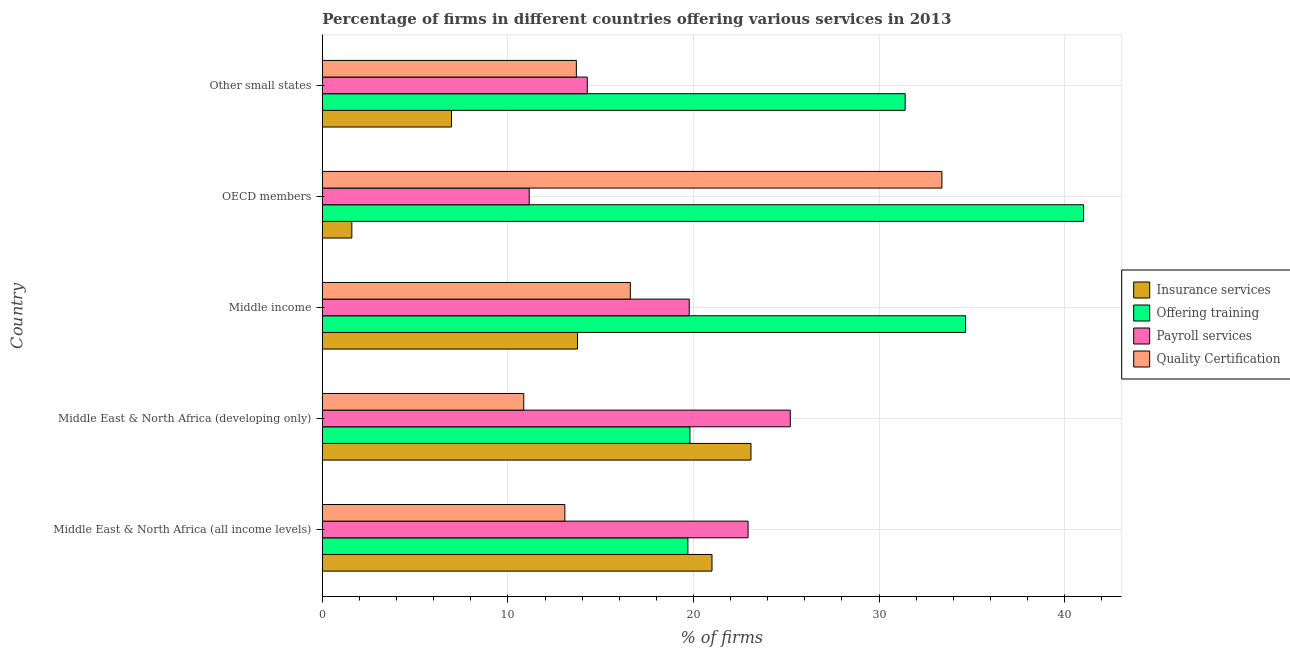How many groups of bars are there?
Provide a succinct answer. 5. Are the number of bars per tick equal to the number of legend labels?
Make the answer very short. Yes. How many bars are there on the 3rd tick from the bottom?
Offer a very short reply. 4. What is the label of the 4th group of bars from the top?
Provide a succinct answer. Middle East & North Africa (developing only). In how many cases, is the number of bars for a given country not equal to the number of legend labels?
Provide a short and direct response. 0. What is the percentage of firms offering quality certification in OECD members?
Keep it short and to the point. 33.39. Across all countries, what is the maximum percentage of firms offering quality certification?
Give a very brief answer. 33.39. Across all countries, what is the minimum percentage of firms offering insurance services?
Provide a succinct answer. 1.59. In which country was the percentage of firms offering payroll services maximum?
Offer a terse response. Middle East & North Africa (developing only). In which country was the percentage of firms offering quality certification minimum?
Offer a very short reply. Middle East & North Africa (developing only). What is the total percentage of firms offering quality certification in the graph?
Offer a terse response. 87.61. What is the difference between the percentage of firms offering insurance services in Middle income and that in Other small states?
Provide a short and direct response. 6.79. What is the difference between the percentage of firms offering quality certification in Middle income and the percentage of firms offering insurance services in Other small states?
Offer a very short reply. 9.64. What is the average percentage of firms offering payroll services per country?
Provide a succinct answer. 18.67. What is the difference between the percentage of firms offering payroll services and percentage of firms offering training in Other small states?
Your answer should be very brief. -17.13. In how many countries, is the percentage of firms offering quality certification greater than 24 %?
Provide a succinct answer. 1. What is the ratio of the percentage of firms offering insurance services in Middle East & North Africa (all income levels) to that in Middle income?
Your response must be concise. 1.53. Is the percentage of firms offering payroll services in Middle East & North Africa (developing only) less than that in OECD members?
Ensure brevity in your answer.  No. What is the difference between the highest and the second highest percentage of firms offering training?
Your answer should be compact. 6.36. What is the difference between the highest and the lowest percentage of firms offering insurance services?
Provide a short and direct response. 21.51. Is the sum of the percentage of firms offering training in Middle income and OECD members greater than the maximum percentage of firms offering insurance services across all countries?
Provide a succinct answer. Yes. Is it the case that in every country, the sum of the percentage of firms offering training and percentage of firms offering quality certification is greater than the sum of percentage of firms offering insurance services and percentage of firms offering payroll services?
Your answer should be compact. No. What does the 2nd bar from the top in Middle East & North Africa (developing only) represents?
Make the answer very short. Payroll services. What does the 3rd bar from the bottom in Other small states represents?
Your response must be concise. Payroll services. Is it the case that in every country, the sum of the percentage of firms offering insurance services and percentage of firms offering training is greater than the percentage of firms offering payroll services?
Your answer should be very brief. Yes. Are all the bars in the graph horizontal?
Keep it short and to the point. Yes. How many countries are there in the graph?
Keep it short and to the point. 5. What is the difference between two consecutive major ticks on the X-axis?
Give a very brief answer. 10. Does the graph contain grids?
Keep it short and to the point. Yes. What is the title of the graph?
Ensure brevity in your answer.  Percentage of firms in different countries offering various services in 2013. What is the label or title of the X-axis?
Offer a terse response. % of firms. What is the % of firms of Insurance services in Middle East & North Africa (all income levels)?
Keep it short and to the point. 21. What is the % of firms in Offering training in Middle East & North Africa (all income levels)?
Offer a terse response. 19.7. What is the % of firms of Payroll services in Middle East & North Africa (all income levels)?
Give a very brief answer. 22.95. What is the % of firms of Quality Certification in Middle East & North Africa (all income levels)?
Provide a short and direct response. 13.07. What is the % of firms of Insurance services in Middle East & North Africa (developing only)?
Your answer should be compact. 23.1. What is the % of firms of Offering training in Middle East & North Africa (developing only)?
Make the answer very short. 19.81. What is the % of firms in Payroll services in Middle East & North Africa (developing only)?
Offer a very short reply. 25.22. What is the % of firms in Quality Certification in Middle East & North Africa (developing only)?
Offer a very short reply. 10.86. What is the % of firms in Insurance services in Middle income?
Keep it short and to the point. 13.75. What is the % of firms of Offering training in Middle income?
Offer a very short reply. 34.66. What is the % of firms in Payroll services in Middle income?
Offer a very short reply. 19.77. What is the % of firms in Quality Certification in Middle income?
Your answer should be very brief. 16.6. What is the % of firms in Insurance services in OECD members?
Provide a succinct answer. 1.59. What is the % of firms of Offering training in OECD members?
Provide a short and direct response. 41.03. What is the % of firms in Payroll services in OECD members?
Your answer should be compact. 11.15. What is the % of firms of Quality Certification in OECD members?
Provide a short and direct response. 33.39. What is the % of firms of Insurance services in Other small states?
Your answer should be very brief. 6.96. What is the % of firms of Offering training in Other small states?
Your response must be concise. 31.41. What is the % of firms in Payroll services in Other small states?
Offer a terse response. 14.28. What is the % of firms of Quality Certification in Other small states?
Make the answer very short. 13.69. Across all countries, what is the maximum % of firms in Insurance services?
Your response must be concise. 23.1. Across all countries, what is the maximum % of firms in Offering training?
Offer a terse response. 41.03. Across all countries, what is the maximum % of firms of Payroll services?
Your response must be concise. 25.22. Across all countries, what is the maximum % of firms of Quality Certification?
Offer a very short reply. 33.39. Across all countries, what is the minimum % of firms of Insurance services?
Keep it short and to the point. 1.59. Across all countries, what is the minimum % of firms of Payroll services?
Ensure brevity in your answer.  11.15. Across all countries, what is the minimum % of firms of Quality Certification?
Offer a terse response. 10.86. What is the total % of firms in Insurance services in the graph?
Your answer should be compact. 66.4. What is the total % of firms of Offering training in the graph?
Keep it short and to the point. 146.61. What is the total % of firms in Payroll services in the graph?
Your response must be concise. 93.37. What is the total % of firms of Quality Certification in the graph?
Your answer should be very brief. 87.61. What is the difference between the % of firms of Insurance services in Middle East & North Africa (all income levels) and that in Middle East & North Africa (developing only)?
Your answer should be very brief. -2.1. What is the difference between the % of firms of Offering training in Middle East & North Africa (all income levels) and that in Middle East & North Africa (developing only)?
Your response must be concise. -0.11. What is the difference between the % of firms of Payroll services in Middle East & North Africa (all income levels) and that in Middle East & North Africa (developing only)?
Provide a succinct answer. -2.27. What is the difference between the % of firms of Quality Certification in Middle East & North Africa (all income levels) and that in Middle East & North Africa (developing only)?
Keep it short and to the point. 2.21. What is the difference between the % of firms of Insurance services in Middle East & North Africa (all income levels) and that in Middle income?
Provide a short and direct response. 7.25. What is the difference between the % of firms in Offering training in Middle East & North Africa (all income levels) and that in Middle income?
Ensure brevity in your answer.  -14.96. What is the difference between the % of firms of Payroll services in Middle East & North Africa (all income levels) and that in Middle income?
Your answer should be very brief. 3.17. What is the difference between the % of firms of Quality Certification in Middle East & North Africa (all income levels) and that in Middle income?
Make the answer very short. -3.53. What is the difference between the % of firms of Insurance services in Middle East & North Africa (all income levels) and that in OECD members?
Ensure brevity in your answer.  19.41. What is the difference between the % of firms of Offering training in Middle East & North Africa (all income levels) and that in OECD members?
Offer a very short reply. -21.33. What is the difference between the % of firms in Payroll services in Middle East & North Africa (all income levels) and that in OECD members?
Make the answer very short. 11.8. What is the difference between the % of firms in Quality Certification in Middle East & North Africa (all income levels) and that in OECD members?
Make the answer very short. -20.32. What is the difference between the % of firms in Insurance services in Middle East & North Africa (all income levels) and that in Other small states?
Offer a very short reply. 14.04. What is the difference between the % of firms of Offering training in Middle East & North Africa (all income levels) and that in Other small states?
Ensure brevity in your answer.  -11.71. What is the difference between the % of firms in Payroll services in Middle East & North Africa (all income levels) and that in Other small states?
Keep it short and to the point. 8.67. What is the difference between the % of firms of Quality Certification in Middle East & North Africa (all income levels) and that in Other small states?
Your response must be concise. -0.62. What is the difference between the % of firms in Insurance services in Middle East & North Africa (developing only) and that in Middle income?
Offer a very short reply. 9.35. What is the difference between the % of firms in Offering training in Middle East & North Africa (developing only) and that in Middle income?
Provide a short and direct response. -14.85. What is the difference between the % of firms in Payroll services in Middle East & North Africa (developing only) and that in Middle income?
Offer a very short reply. 5.45. What is the difference between the % of firms of Quality Certification in Middle East & North Africa (developing only) and that in Middle income?
Your answer should be very brief. -5.74. What is the difference between the % of firms of Insurance services in Middle East & North Africa (developing only) and that in OECD members?
Your response must be concise. 21.51. What is the difference between the % of firms of Offering training in Middle East & North Africa (developing only) and that in OECD members?
Offer a very short reply. -21.22. What is the difference between the % of firms of Payroll services in Middle East & North Africa (developing only) and that in OECD members?
Provide a succinct answer. 14.07. What is the difference between the % of firms of Quality Certification in Middle East & North Africa (developing only) and that in OECD members?
Your answer should be compact. -22.54. What is the difference between the % of firms of Insurance services in Middle East & North Africa (developing only) and that in Other small states?
Provide a short and direct response. 16.14. What is the difference between the % of firms of Payroll services in Middle East & North Africa (developing only) and that in Other small states?
Your answer should be compact. 10.94. What is the difference between the % of firms of Quality Certification in Middle East & North Africa (developing only) and that in Other small states?
Keep it short and to the point. -2.83. What is the difference between the % of firms of Insurance services in Middle income and that in OECD members?
Keep it short and to the point. 12.16. What is the difference between the % of firms in Offering training in Middle income and that in OECD members?
Provide a short and direct response. -6.36. What is the difference between the % of firms of Payroll services in Middle income and that in OECD members?
Give a very brief answer. 8.62. What is the difference between the % of firms in Quality Certification in Middle income and that in OECD members?
Keep it short and to the point. -16.79. What is the difference between the % of firms in Insurance services in Middle income and that in Other small states?
Your answer should be compact. 6.79. What is the difference between the % of firms in Offering training in Middle income and that in Other small states?
Your response must be concise. 3.25. What is the difference between the % of firms of Payroll services in Middle income and that in Other small states?
Offer a terse response. 5.49. What is the difference between the % of firms of Quality Certification in Middle income and that in Other small states?
Make the answer very short. 2.91. What is the difference between the % of firms of Insurance services in OECD members and that in Other small states?
Your response must be concise. -5.37. What is the difference between the % of firms in Offering training in OECD members and that in Other small states?
Offer a very short reply. 9.62. What is the difference between the % of firms in Payroll services in OECD members and that in Other small states?
Offer a terse response. -3.13. What is the difference between the % of firms in Quality Certification in OECD members and that in Other small states?
Provide a succinct answer. 19.7. What is the difference between the % of firms in Insurance services in Middle East & North Africa (all income levels) and the % of firms in Offering training in Middle East & North Africa (developing only)?
Provide a succinct answer. 1.19. What is the difference between the % of firms of Insurance services in Middle East & North Africa (all income levels) and the % of firms of Payroll services in Middle East & North Africa (developing only)?
Provide a short and direct response. -4.22. What is the difference between the % of firms in Insurance services in Middle East & North Africa (all income levels) and the % of firms in Quality Certification in Middle East & North Africa (developing only)?
Provide a succinct answer. 10.14. What is the difference between the % of firms in Offering training in Middle East & North Africa (all income levels) and the % of firms in Payroll services in Middle East & North Africa (developing only)?
Give a very brief answer. -5.52. What is the difference between the % of firms of Offering training in Middle East & North Africa (all income levels) and the % of firms of Quality Certification in Middle East & North Africa (developing only)?
Keep it short and to the point. 8.84. What is the difference between the % of firms in Payroll services in Middle East & North Africa (all income levels) and the % of firms in Quality Certification in Middle East & North Africa (developing only)?
Make the answer very short. 12.09. What is the difference between the % of firms in Insurance services in Middle East & North Africa (all income levels) and the % of firms in Offering training in Middle income?
Make the answer very short. -13.66. What is the difference between the % of firms in Insurance services in Middle East & North Africa (all income levels) and the % of firms in Payroll services in Middle income?
Offer a very short reply. 1.23. What is the difference between the % of firms of Insurance services in Middle East & North Africa (all income levels) and the % of firms of Quality Certification in Middle income?
Provide a short and direct response. 4.4. What is the difference between the % of firms of Offering training in Middle East & North Africa (all income levels) and the % of firms of Payroll services in Middle income?
Give a very brief answer. -0.07. What is the difference between the % of firms of Offering training in Middle East & North Africa (all income levels) and the % of firms of Quality Certification in Middle income?
Your answer should be compact. 3.1. What is the difference between the % of firms in Payroll services in Middle East & North Africa (all income levels) and the % of firms in Quality Certification in Middle income?
Make the answer very short. 6.35. What is the difference between the % of firms of Insurance services in Middle East & North Africa (all income levels) and the % of firms of Offering training in OECD members?
Give a very brief answer. -20.03. What is the difference between the % of firms in Insurance services in Middle East & North Africa (all income levels) and the % of firms in Payroll services in OECD members?
Make the answer very short. 9.85. What is the difference between the % of firms in Insurance services in Middle East & North Africa (all income levels) and the % of firms in Quality Certification in OECD members?
Provide a short and direct response. -12.39. What is the difference between the % of firms of Offering training in Middle East & North Africa (all income levels) and the % of firms of Payroll services in OECD members?
Provide a succinct answer. 8.55. What is the difference between the % of firms of Offering training in Middle East & North Africa (all income levels) and the % of firms of Quality Certification in OECD members?
Your answer should be very brief. -13.69. What is the difference between the % of firms in Payroll services in Middle East & North Africa (all income levels) and the % of firms in Quality Certification in OECD members?
Your response must be concise. -10.45. What is the difference between the % of firms in Insurance services in Middle East & North Africa (all income levels) and the % of firms in Offering training in Other small states?
Your answer should be very brief. -10.41. What is the difference between the % of firms in Insurance services in Middle East & North Africa (all income levels) and the % of firms in Payroll services in Other small states?
Your response must be concise. 6.72. What is the difference between the % of firms in Insurance services in Middle East & North Africa (all income levels) and the % of firms in Quality Certification in Other small states?
Your response must be concise. 7.31. What is the difference between the % of firms in Offering training in Middle East & North Africa (all income levels) and the % of firms in Payroll services in Other small states?
Make the answer very short. 5.42. What is the difference between the % of firms in Offering training in Middle East & North Africa (all income levels) and the % of firms in Quality Certification in Other small states?
Your response must be concise. 6.01. What is the difference between the % of firms in Payroll services in Middle East & North Africa (all income levels) and the % of firms in Quality Certification in Other small states?
Keep it short and to the point. 9.26. What is the difference between the % of firms in Insurance services in Middle East & North Africa (developing only) and the % of firms in Offering training in Middle income?
Offer a terse response. -11.56. What is the difference between the % of firms of Insurance services in Middle East & North Africa (developing only) and the % of firms of Payroll services in Middle income?
Give a very brief answer. 3.33. What is the difference between the % of firms in Insurance services in Middle East & North Africa (developing only) and the % of firms in Quality Certification in Middle income?
Your answer should be very brief. 6.5. What is the difference between the % of firms of Offering training in Middle East & North Africa (developing only) and the % of firms of Payroll services in Middle income?
Your response must be concise. 0.04. What is the difference between the % of firms in Offering training in Middle East & North Africa (developing only) and the % of firms in Quality Certification in Middle income?
Ensure brevity in your answer.  3.21. What is the difference between the % of firms of Payroll services in Middle East & North Africa (developing only) and the % of firms of Quality Certification in Middle income?
Give a very brief answer. 8.62. What is the difference between the % of firms in Insurance services in Middle East & North Africa (developing only) and the % of firms in Offering training in OECD members?
Offer a very short reply. -17.93. What is the difference between the % of firms of Insurance services in Middle East & North Africa (developing only) and the % of firms of Payroll services in OECD members?
Your response must be concise. 11.95. What is the difference between the % of firms in Insurance services in Middle East & North Africa (developing only) and the % of firms in Quality Certification in OECD members?
Give a very brief answer. -10.29. What is the difference between the % of firms in Offering training in Middle East & North Africa (developing only) and the % of firms in Payroll services in OECD members?
Provide a short and direct response. 8.66. What is the difference between the % of firms of Offering training in Middle East & North Africa (developing only) and the % of firms of Quality Certification in OECD members?
Provide a succinct answer. -13.58. What is the difference between the % of firms in Payroll services in Middle East & North Africa (developing only) and the % of firms in Quality Certification in OECD members?
Give a very brief answer. -8.17. What is the difference between the % of firms of Insurance services in Middle East & North Africa (developing only) and the % of firms of Offering training in Other small states?
Offer a very short reply. -8.31. What is the difference between the % of firms of Insurance services in Middle East & North Africa (developing only) and the % of firms of Payroll services in Other small states?
Provide a short and direct response. 8.82. What is the difference between the % of firms of Insurance services in Middle East & North Africa (developing only) and the % of firms of Quality Certification in Other small states?
Ensure brevity in your answer.  9.41. What is the difference between the % of firms in Offering training in Middle East & North Africa (developing only) and the % of firms in Payroll services in Other small states?
Your answer should be very brief. 5.53. What is the difference between the % of firms of Offering training in Middle East & North Africa (developing only) and the % of firms of Quality Certification in Other small states?
Your response must be concise. 6.12. What is the difference between the % of firms in Payroll services in Middle East & North Africa (developing only) and the % of firms in Quality Certification in Other small states?
Make the answer very short. 11.53. What is the difference between the % of firms of Insurance services in Middle income and the % of firms of Offering training in OECD members?
Your answer should be compact. -27.28. What is the difference between the % of firms in Insurance services in Middle income and the % of firms in Payroll services in OECD members?
Your response must be concise. 2.6. What is the difference between the % of firms of Insurance services in Middle income and the % of firms of Quality Certification in OECD members?
Provide a succinct answer. -19.64. What is the difference between the % of firms in Offering training in Middle income and the % of firms in Payroll services in OECD members?
Your answer should be compact. 23.51. What is the difference between the % of firms in Offering training in Middle income and the % of firms in Quality Certification in OECD members?
Your response must be concise. 1.27. What is the difference between the % of firms of Payroll services in Middle income and the % of firms of Quality Certification in OECD members?
Give a very brief answer. -13.62. What is the difference between the % of firms in Insurance services in Middle income and the % of firms in Offering training in Other small states?
Keep it short and to the point. -17.66. What is the difference between the % of firms of Insurance services in Middle income and the % of firms of Payroll services in Other small states?
Keep it short and to the point. -0.53. What is the difference between the % of firms of Insurance services in Middle income and the % of firms of Quality Certification in Other small states?
Your response must be concise. 0.06. What is the difference between the % of firms in Offering training in Middle income and the % of firms in Payroll services in Other small states?
Make the answer very short. 20.38. What is the difference between the % of firms in Offering training in Middle income and the % of firms in Quality Certification in Other small states?
Keep it short and to the point. 20.97. What is the difference between the % of firms in Payroll services in Middle income and the % of firms in Quality Certification in Other small states?
Offer a terse response. 6.08. What is the difference between the % of firms of Insurance services in OECD members and the % of firms of Offering training in Other small states?
Provide a succinct answer. -29.82. What is the difference between the % of firms of Insurance services in OECD members and the % of firms of Payroll services in Other small states?
Keep it short and to the point. -12.69. What is the difference between the % of firms of Insurance services in OECD members and the % of firms of Quality Certification in Other small states?
Give a very brief answer. -12.1. What is the difference between the % of firms of Offering training in OECD members and the % of firms of Payroll services in Other small states?
Keep it short and to the point. 26.75. What is the difference between the % of firms in Offering training in OECD members and the % of firms in Quality Certification in Other small states?
Keep it short and to the point. 27.34. What is the difference between the % of firms in Payroll services in OECD members and the % of firms in Quality Certification in Other small states?
Make the answer very short. -2.54. What is the average % of firms of Insurance services per country?
Ensure brevity in your answer.  13.28. What is the average % of firms in Offering training per country?
Make the answer very short. 29.32. What is the average % of firms in Payroll services per country?
Keep it short and to the point. 18.67. What is the average % of firms in Quality Certification per country?
Offer a very short reply. 17.52. What is the difference between the % of firms of Insurance services and % of firms of Offering training in Middle East & North Africa (all income levels)?
Provide a succinct answer. 1.3. What is the difference between the % of firms in Insurance services and % of firms in Payroll services in Middle East & North Africa (all income levels)?
Give a very brief answer. -1.95. What is the difference between the % of firms in Insurance services and % of firms in Quality Certification in Middle East & North Africa (all income levels)?
Offer a very short reply. 7.93. What is the difference between the % of firms in Offering training and % of firms in Payroll services in Middle East & North Africa (all income levels)?
Keep it short and to the point. -3.25. What is the difference between the % of firms in Offering training and % of firms in Quality Certification in Middle East & North Africa (all income levels)?
Offer a terse response. 6.63. What is the difference between the % of firms of Payroll services and % of firms of Quality Certification in Middle East & North Africa (all income levels)?
Give a very brief answer. 9.88. What is the difference between the % of firms of Insurance services and % of firms of Offering training in Middle East & North Africa (developing only)?
Your answer should be very brief. 3.29. What is the difference between the % of firms in Insurance services and % of firms in Payroll services in Middle East & North Africa (developing only)?
Offer a terse response. -2.12. What is the difference between the % of firms of Insurance services and % of firms of Quality Certification in Middle East & North Africa (developing only)?
Keep it short and to the point. 12.24. What is the difference between the % of firms in Offering training and % of firms in Payroll services in Middle East & North Africa (developing only)?
Give a very brief answer. -5.41. What is the difference between the % of firms of Offering training and % of firms of Quality Certification in Middle East & North Africa (developing only)?
Provide a short and direct response. 8.95. What is the difference between the % of firms of Payroll services and % of firms of Quality Certification in Middle East & North Africa (developing only)?
Give a very brief answer. 14.36. What is the difference between the % of firms in Insurance services and % of firms in Offering training in Middle income?
Provide a succinct answer. -20.91. What is the difference between the % of firms of Insurance services and % of firms of Payroll services in Middle income?
Provide a succinct answer. -6.02. What is the difference between the % of firms of Insurance services and % of firms of Quality Certification in Middle income?
Provide a short and direct response. -2.85. What is the difference between the % of firms in Offering training and % of firms in Payroll services in Middle income?
Your answer should be very brief. 14.89. What is the difference between the % of firms of Offering training and % of firms of Quality Certification in Middle income?
Keep it short and to the point. 18.07. What is the difference between the % of firms in Payroll services and % of firms in Quality Certification in Middle income?
Offer a very short reply. 3.17. What is the difference between the % of firms of Insurance services and % of firms of Offering training in OECD members?
Your response must be concise. -39.44. What is the difference between the % of firms of Insurance services and % of firms of Payroll services in OECD members?
Provide a succinct answer. -9.56. What is the difference between the % of firms in Insurance services and % of firms in Quality Certification in OECD members?
Ensure brevity in your answer.  -31.8. What is the difference between the % of firms in Offering training and % of firms in Payroll services in OECD members?
Give a very brief answer. 29.88. What is the difference between the % of firms in Offering training and % of firms in Quality Certification in OECD members?
Your answer should be compact. 7.64. What is the difference between the % of firms of Payroll services and % of firms of Quality Certification in OECD members?
Make the answer very short. -22.24. What is the difference between the % of firms of Insurance services and % of firms of Offering training in Other small states?
Your answer should be compact. -24.45. What is the difference between the % of firms of Insurance services and % of firms of Payroll services in Other small states?
Offer a terse response. -7.32. What is the difference between the % of firms of Insurance services and % of firms of Quality Certification in Other small states?
Make the answer very short. -6.73. What is the difference between the % of firms in Offering training and % of firms in Payroll services in Other small states?
Offer a terse response. 17.13. What is the difference between the % of firms in Offering training and % of firms in Quality Certification in Other small states?
Give a very brief answer. 17.72. What is the difference between the % of firms in Payroll services and % of firms in Quality Certification in Other small states?
Provide a succinct answer. 0.59. What is the ratio of the % of firms of Insurance services in Middle East & North Africa (all income levels) to that in Middle East & North Africa (developing only)?
Give a very brief answer. 0.91. What is the ratio of the % of firms of Payroll services in Middle East & North Africa (all income levels) to that in Middle East & North Africa (developing only)?
Your response must be concise. 0.91. What is the ratio of the % of firms in Quality Certification in Middle East & North Africa (all income levels) to that in Middle East & North Africa (developing only)?
Provide a succinct answer. 1.2. What is the ratio of the % of firms of Insurance services in Middle East & North Africa (all income levels) to that in Middle income?
Provide a succinct answer. 1.53. What is the ratio of the % of firms in Offering training in Middle East & North Africa (all income levels) to that in Middle income?
Make the answer very short. 0.57. What is the ratio of the % of firms in Payroll services in Middle East & North Africa (all income levels) to that in Middle income?
Your answer should be very brief. 1.16. What is the ratio of the % of firms in Quality Certification in Middle East & North Africa (all income levels) to that in Middle income?
Give a very brief answer. 0.79. What is the ratio of the % of firms in Insurance services in Middle East & North Africa (all income levels) to that in OECD members?
Your response must be concise. 13.2. What is the ratio of the % of firms in Offering training in Middle East & North Africa (all income levels) to that in OECD members?
Keep it short and to the point. 0.48. What is the ratio of the % of firms in Payroll services in Middle East & North Africa (all income levels) to that in OECD members?
Provide a succinct answer. 2.06. What is the ratio of the % of firms in Quality Certification in Middle East & North Africa (all income levels) to that in OECD members?
Your answer should be very brief. 0.39. What is the ratio of the % of firms of Insurance services in Middle East & North Africa (all income levels) to that in Other small states?
Offer a terse response. 3.02. What is the ratio of the % of firms of Offering training in Middle East & North Africa (all income levels) to that in Other small states?
Your answer should be compact. 0.63. What is the ratio of the % of firms in Payroll services in Middle East & North Africa (all income levels) to that in Other small states?
Make the answer very short. 1.61. What is the ratio of the % of firms in Quality Certification in Middle East & North Africa (all income levels) to that in Other small states?
Provide a succinct answer. 0.95. What is the ratio of the % of firms in Insurance services in Middle East & North Africa (developing only) to that in Middle income?
Ensure brevity in your answer.  1.68. What is the ratio of the % of firms in Offering training in Middle East & North Africa (developing only) to that in Middle income?
Provide a succinct answer. 0.57. What is the ratio of the % of firms of Payroll services in Middle East & North Africa (developing only) to that in Middle income?
Give a very brief answer. 1.28. What is the ratio of the % of firms in Quality Certification in Middle East & North Africa (developing only) to that in Middle income?
Provide a succinct answer. 0.65. What is the ratio of the % of firms in Insurance services in Middle East & North Africa (developing only) to that in OECD members?
Offer a terse response. 14.52. What is the ratio of the % of firms in Offering training in Middle East & North Africa (developing only) to that in OECD members?
Your answer should be very brief. 0.48. What is the ratio of the % of firms in Payroll services in Middle East & North Africa (developing only) to that in OECD members?
Provide a short and direct response. 2.26. What is the ratio of the % of firms in Quality Certification in Middle East & North Africa (developing only) to that in OECD members?
Your answer should be compact. 0.33. What is the ratio of the % of firms of Insurance services in Middle East & North Africa (developing only) to that in Other small states?
Keep it short and to the point. 3.32. What is the ratio of the % of firms of Offering training in Middle East & North Africa (developing only) to that in Other small states?
Your response must be concise. 0.63. What is the ratio of the % of firms in Payroll services in Middle East & North Africa (developing only) to that in Other small states?
Provide a succinct answer. 1.77. What is the ratio of the % of firms of Quality Certification in Middle East & North Africa (developing only) to that in Other small states?
Make the answer very short. 0.79. What is the ratio of the % of firms in Insurance services in Middle income to that in OECD members?
Ensure brevity in your answer.  8.64. What is the ratio of the % of firms of Offering training in Middle income to that in OECD members?
Ensure brevity in your answer.  0.84. What is the ratio of the % of firms of Payroll services in Middle income to that in OECD members?
Your response must be concise. 1.77. What is the ratio of the % of firms of Quality Certification in Middle income to that in OECD members?
Your response must be concise. 0.5. What is the ratio of the % of firms of Insurance services in Middle income to that in Other small states?
Your answer should be very brief. 1.98. What is the ratio of the % of firms of Offering training in Middle income to that in Other small states?
Give a very brief answer. 1.1. What is the ratio of the % of firms of Payroll services in Middle income to that in Other small states?
Ensure brevity in your answer.  1.38. What is the ratio of the % of firms of Quality Certification in Middle income to that in Other small states?
Give a very brief answer. 1.21. What is the ratio of the % of firms in Insurance services in OECD members to that in Other small states?
Make the answer very short. 0.23. What is the ratio of the % of firms of Offering training in OECD members to that in Other small states?
Provide a succinct answer. 1.31. What is the ratio of the % of firms of Payroll services in OECD members to that in Other small states?
Offer a very short reply. 0.78. What is the ratio of the % of firms of Quality Certification in OECD members to that in Other small states?
Give a very brief answer. 2.44. What is the difference between the highest and the second highest % of firms in Offering training?
Keep it short and to the point. 6.36. What is the difference between the highest and the second highest % of firms in Payroll services?
Make the answer very short. 2.27. What is the difference between the highest and the second highest % of firms of Quality Certification?
Your answer should be very brief. 16.79. What is the difference between the highest and the lowest % of firms in Insurance services?
Provide a short and direct response. 21.51. What is the difference between the highest and the lowest % of firms in Offering training?
Make the answer very short. 21.33. What is the difference between the highest and the lowest % of firms of Payroll services?
Your response must be concise. 14.07. What is the difference between the highest and the lowest % of firms in Quality Certification?
Ensure brevity in your answer.  22.54. 